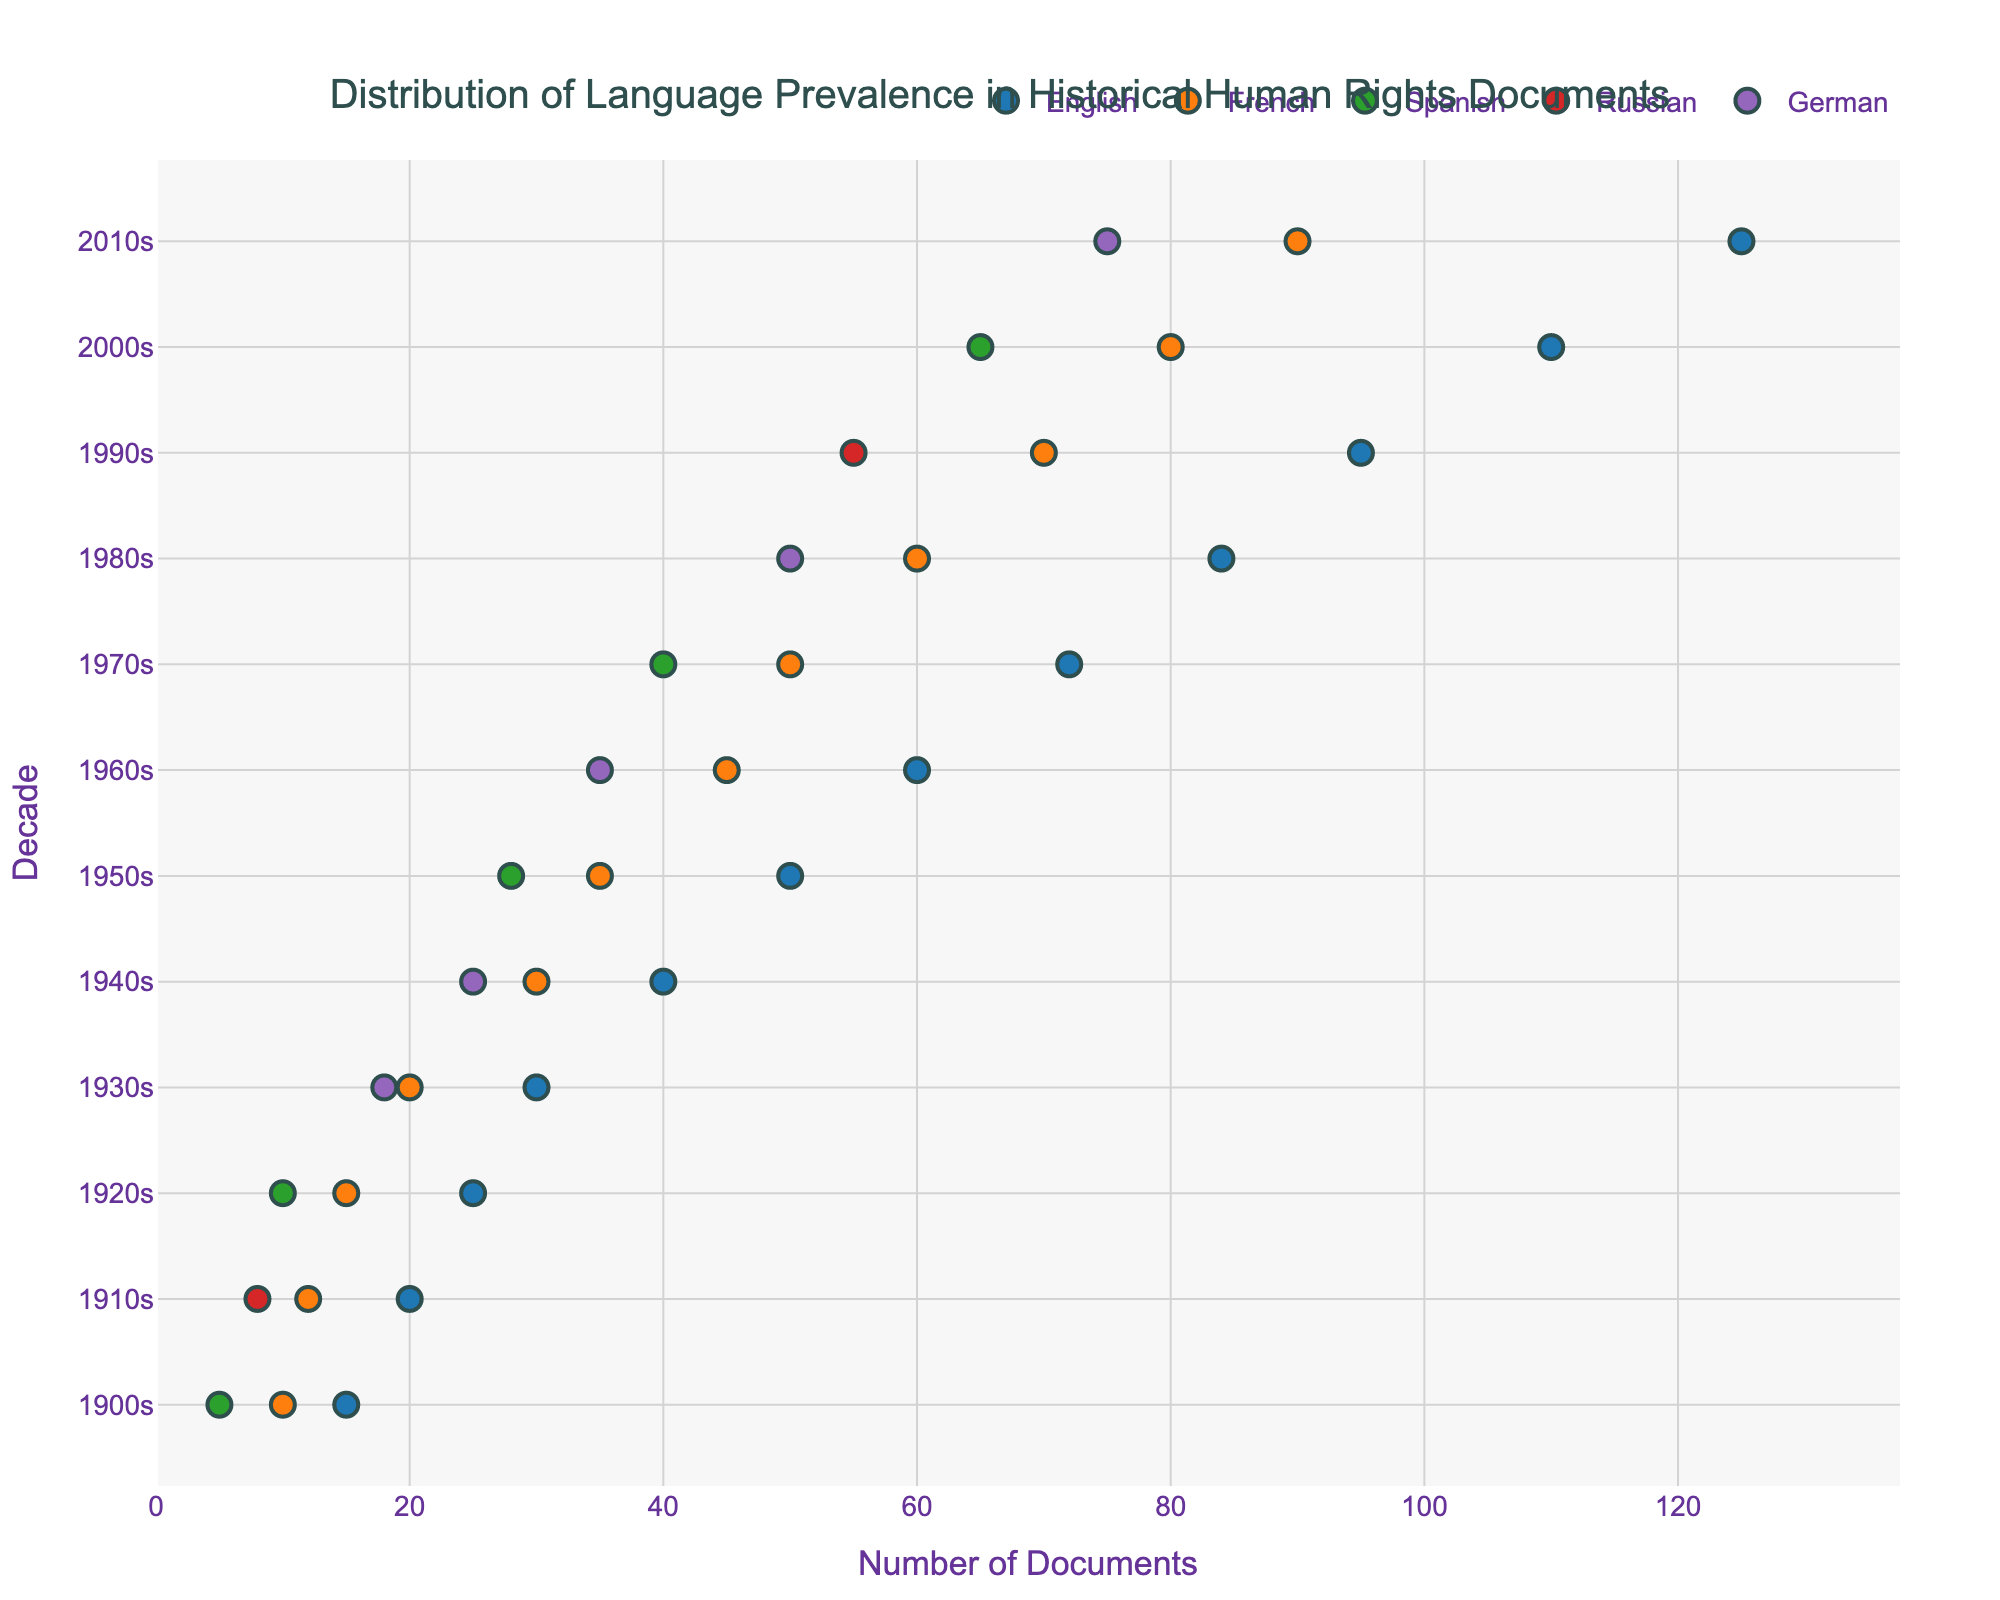What's the title of the figure? The title of the figure is prominently displayed at the top of the graphical representation.
Answer: Distribution of Language Prevalence in Historical Human Rights Documents Which language has the most documents in the 2000s? By examining the data points within the 2000s row, one can identify which language dot is positioned highest on the x-axis.
Answer: English How many documents are there in French during the 1930s? Find the data point corresponding to French in the 1930s row and read the value on the x-axis.
Answer: 20 Which languages are represented in the figure? Each marked data point represents a unique language, with different colors distinguishing them. The legend helps to identify each language.
Answer: English, French, Spanish, Russian, German What is the average number of English documents between the 1900s and 1910s? Sum the number of English documents in the 1900s and 1910s, then divide by the number of decades (2). (15 + 20) / 2 = 17.5
Answer: 17.5 Which decade shows the highest increase in French documents compared to the previous decade? Calculate the increase in French documents for each decade compared to the previous decade and identify the decade with the highest increase. The highest increase is from the 1960s to the 1970s (50 - 45 = 5).
Answer: 1970s How does the distribution of German documents change from the 1930s to the 1940s? Compare the position of the dots for German in the 1930s and 1940s. The document count increases from 18 in the 1930s to 25 in the 1940s, indicating a rise.
Answer: Increase In which decade did Spanish first appear in the dataset? Identify the first decade where a data point for Spanish is present. The first appearance is in the 1900s.
Answer: 1900s How does the number of Spanish documents in the 2010s compare to the 1980s? Compare the Spanish document counts for the 2010s and 1980s. Spanish had 65 documents in the 2010s and 40 in the 1980s, resulting in an increase.
Answer: Increase What is the range of document counts for Russian documents across all decades shown? Identify the maximum and minimum document counts for Russian and find the difference. The maximum is 55 (1990s) and minimum is 8 (1910s). The range is 55 - 8 = 47.
Answer: 47 